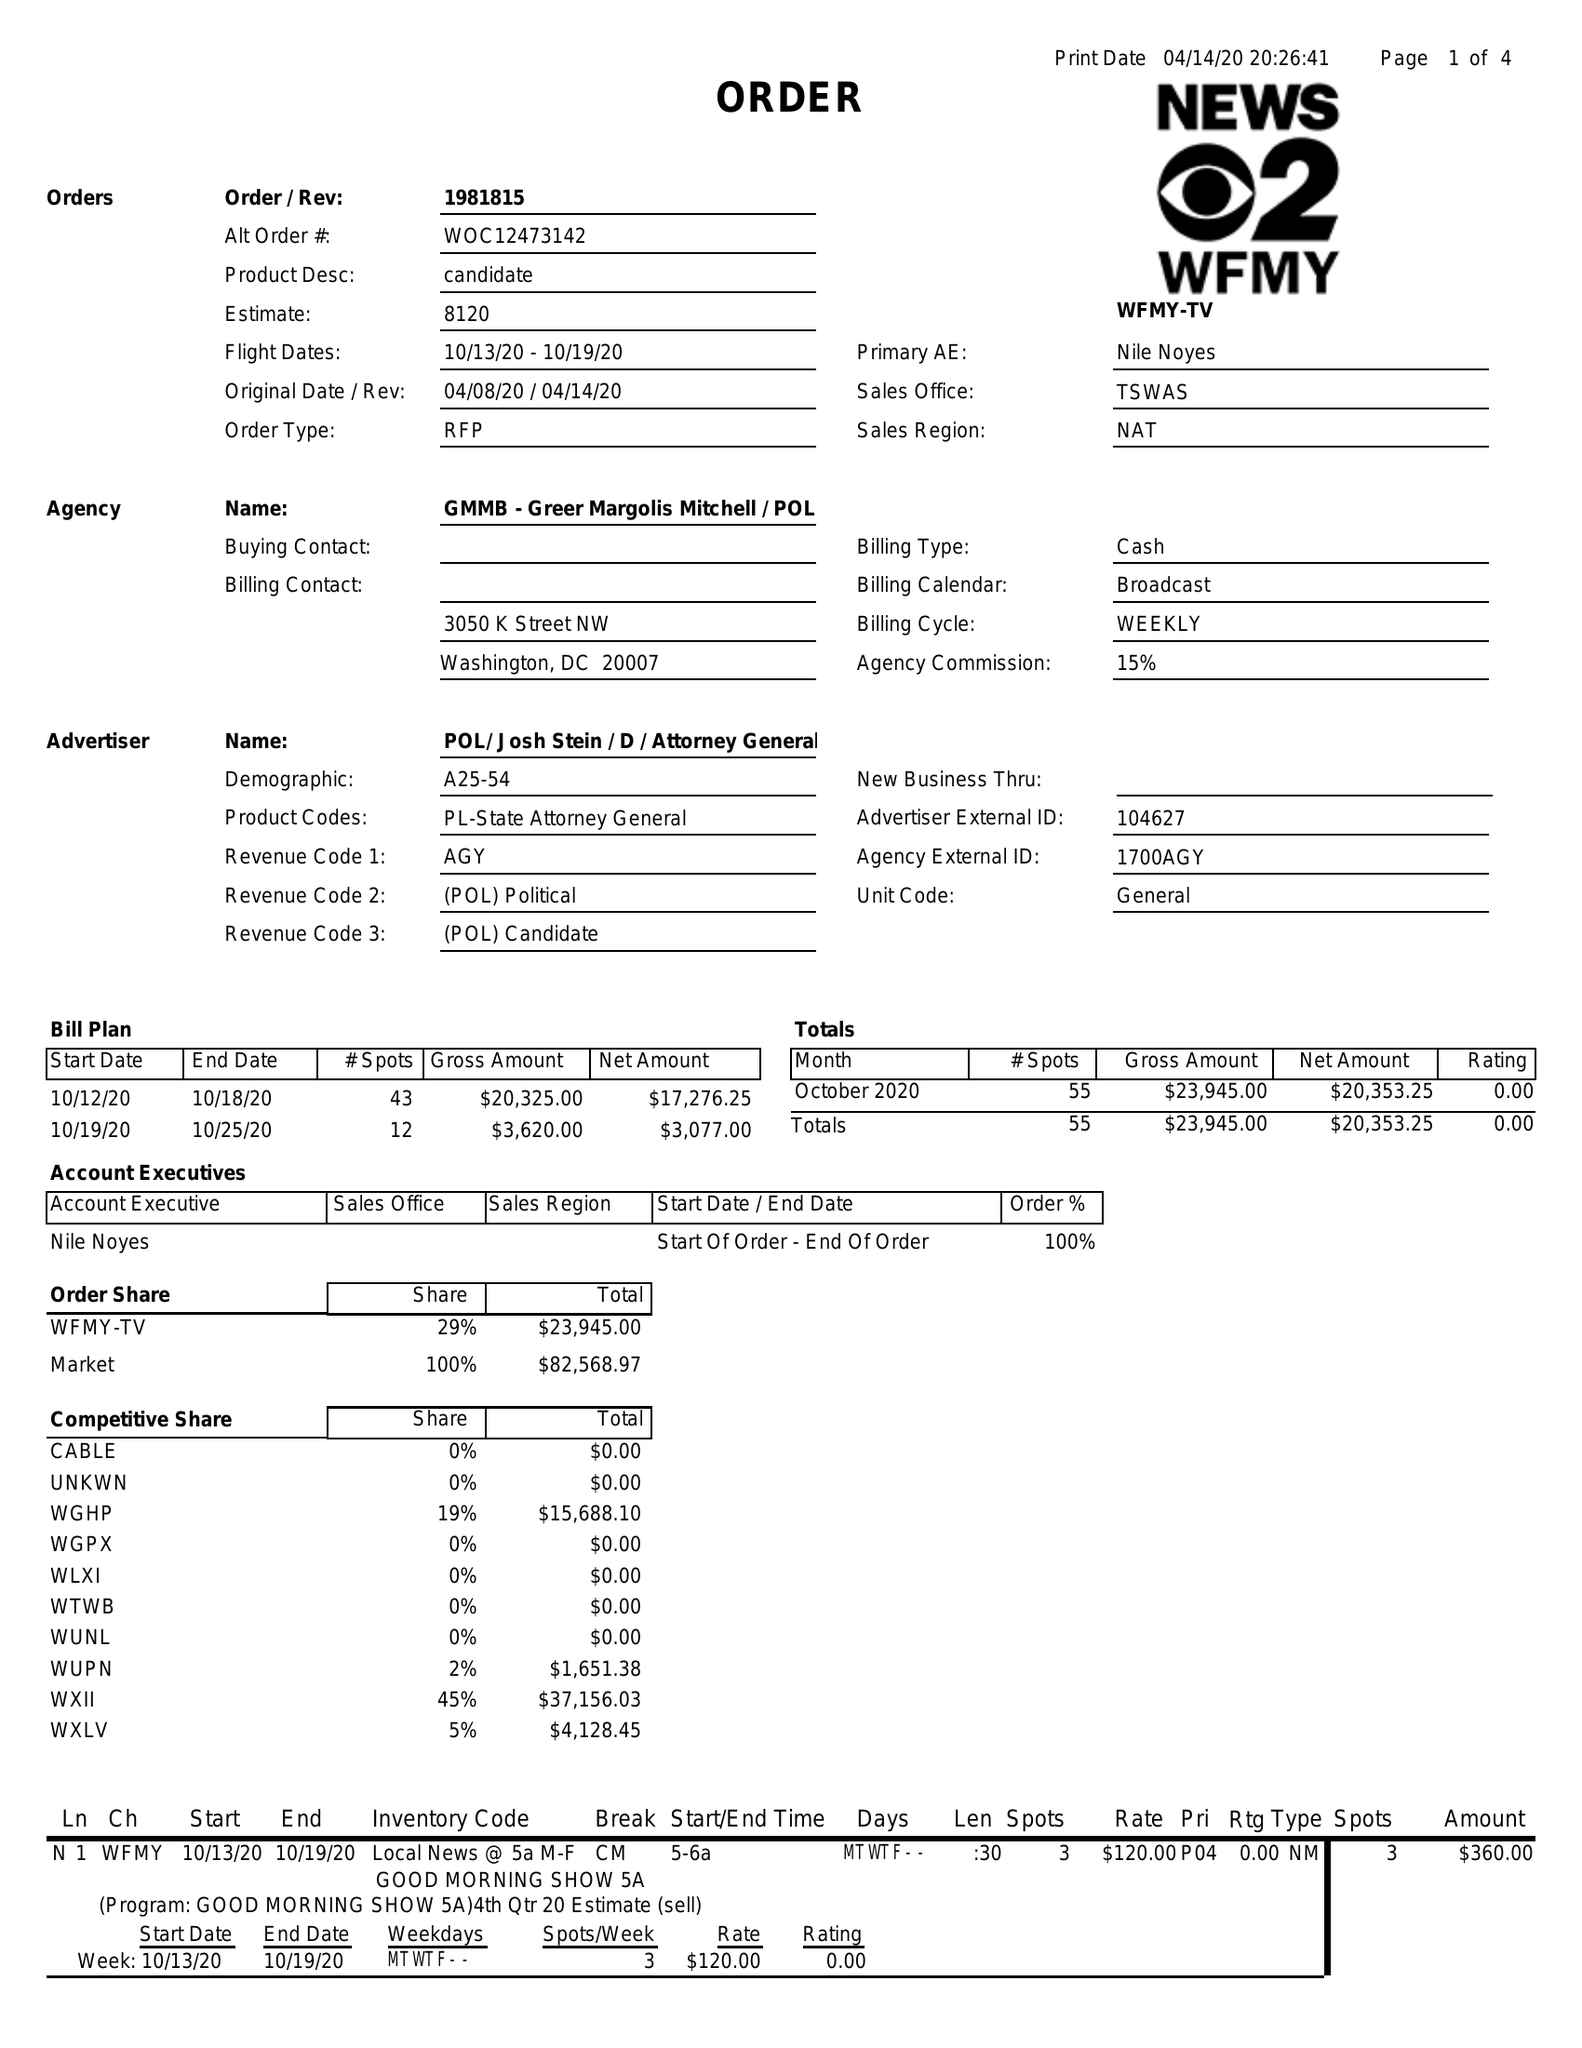What is the value for the advertiser?
Answer the question using a single word or phrase. POL/JOSHSTEIN/D/ATTORNEYGENERAL 